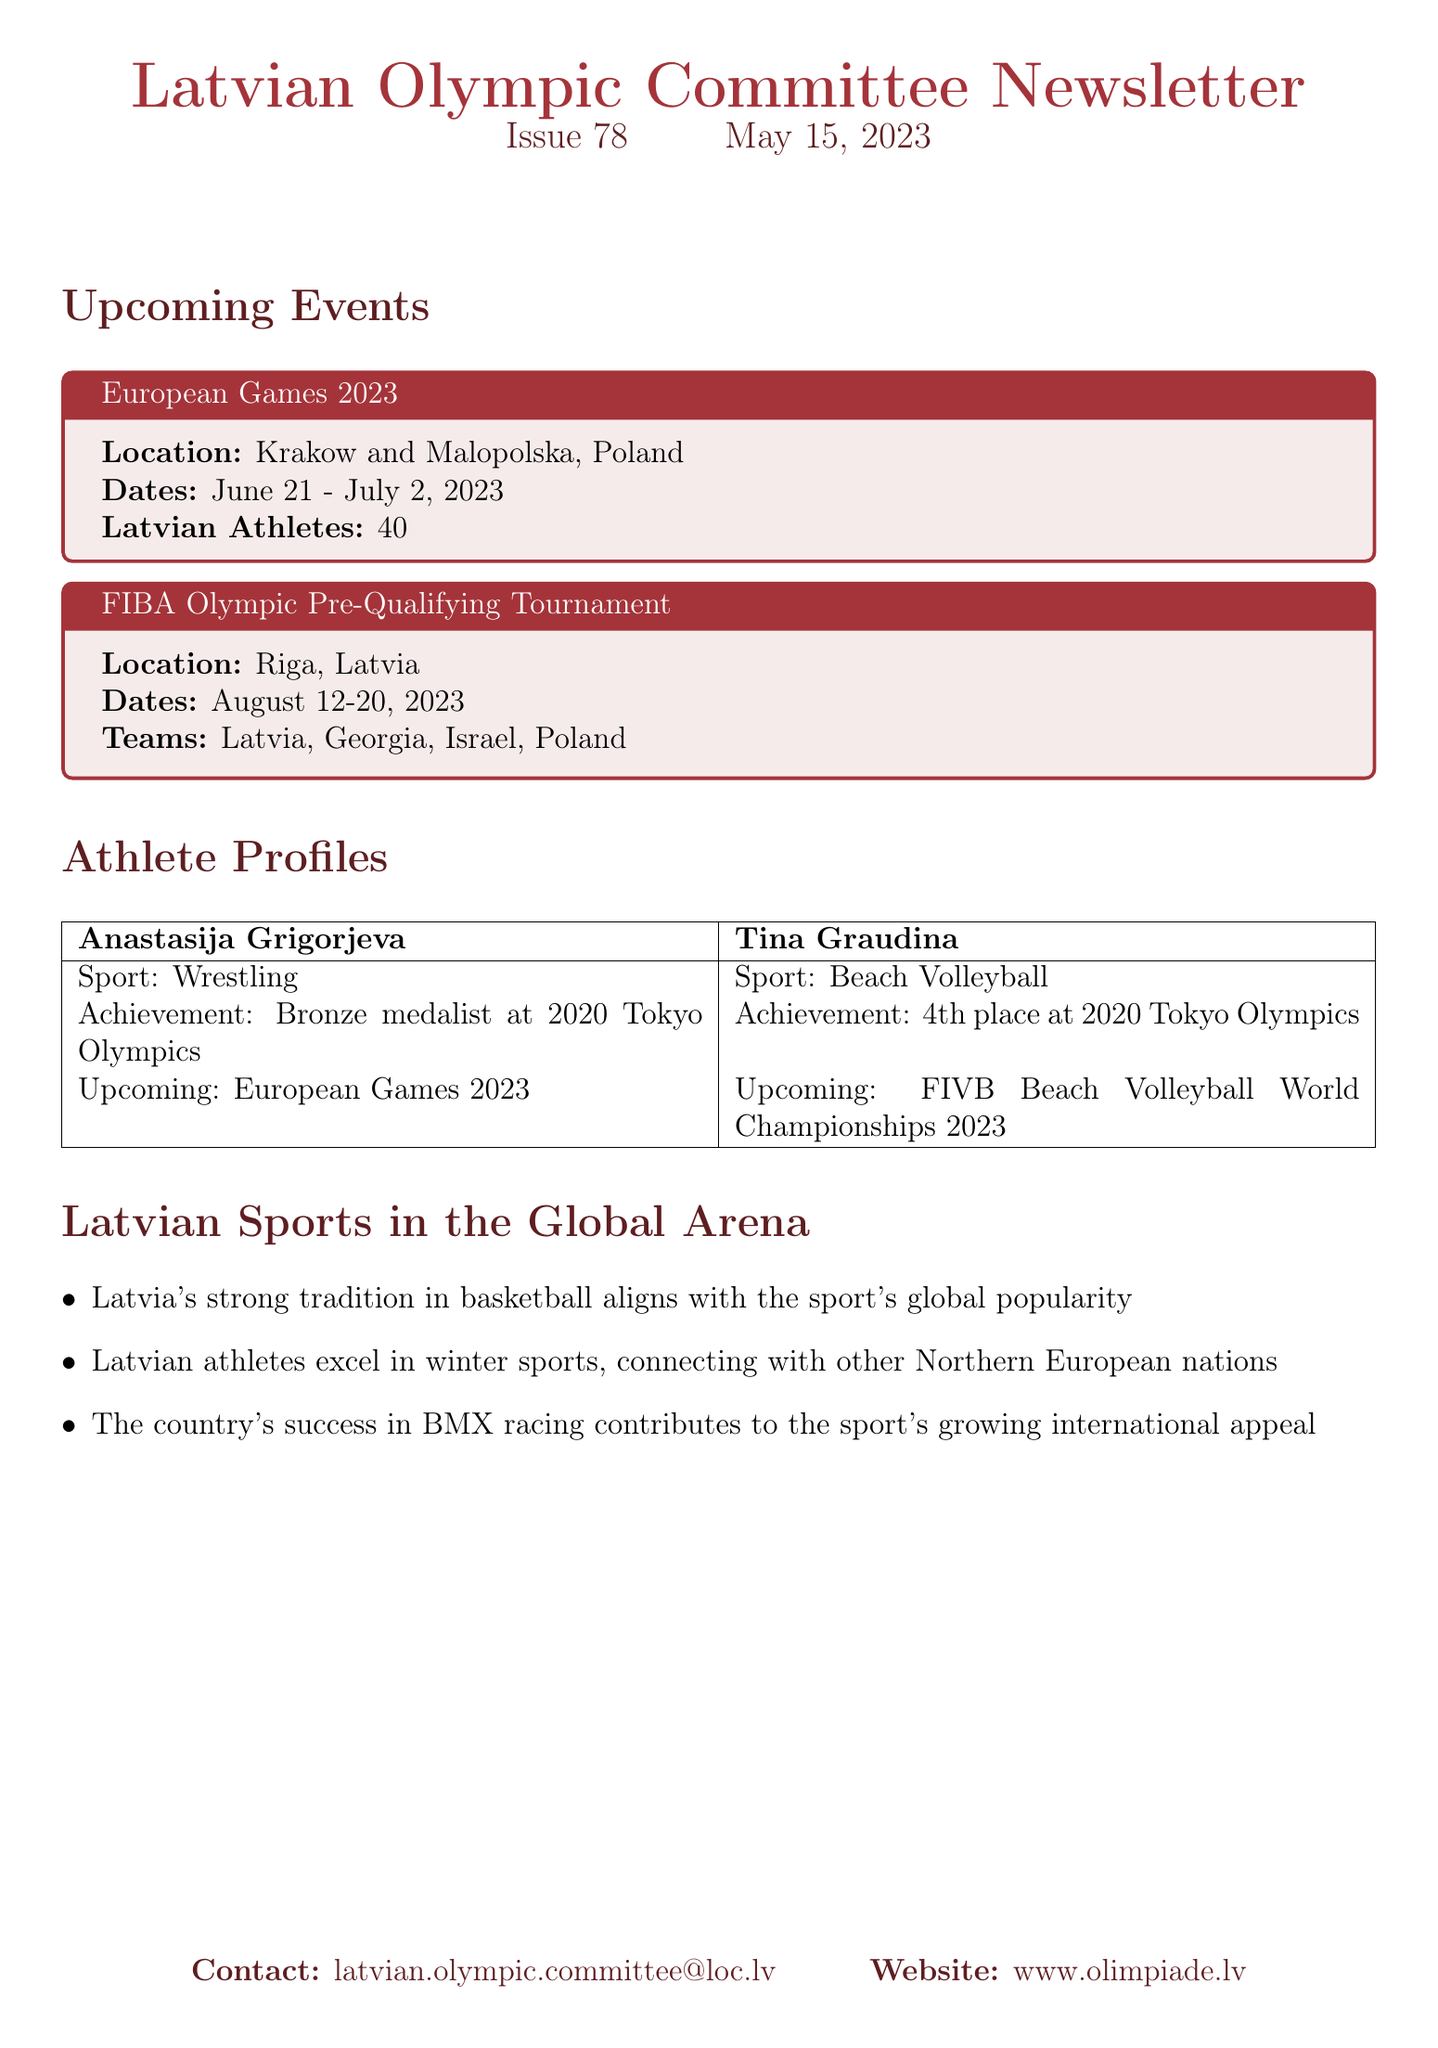What are the dates for the European Games 2023? The document states that the European Games will take place from June 21 to July 2, 2023.
Answer: June 21 - July 2, 2023 How many Latvian athletes are participating in the European Games 2023? The document mentions that 40 Latvian athletes will participate in the European Games 2023.
Answer: 40 Who is a bronze medalist at the 2020 Tokyo Olympics? Anastasija Grigorjeva is noted as the bronze medalist at the 2020 Tokyo Olympics in the document.
Answer: Anastasija Grigorjeva Which sport does Tina Graudina compete in? According to the athlete profiles, Tina Graudina competes in beach volleyball.
Answer: Beach Volleyball What is the location for the FIBA Olympic Pre-Qualifying Tournament? The document indicates that the FIBA Olympic Pre-Qualifying Tournament will take place in Riga, Latvia.
Answer: Riga, Latvia How does Latvia's basketball tradition connect to global sports? The document states that Latvia's strong tradition in basketball aligns with the sport's global popularity.
Answer: Global popularity Which winter sports are emphasized for Latvian athletes? The document highlights that Latvian athletes excel in winter sports, relating them to other Northern European nations.
Answer: Winter sports What will Tina Graudina compete in after the European Games? It is stated that Tina Graudina will compete in the FIVB Beach Volleyball World Championships 2023 after the European Games.
Answer: FIVB Beach Volleyball World Championships 2023 